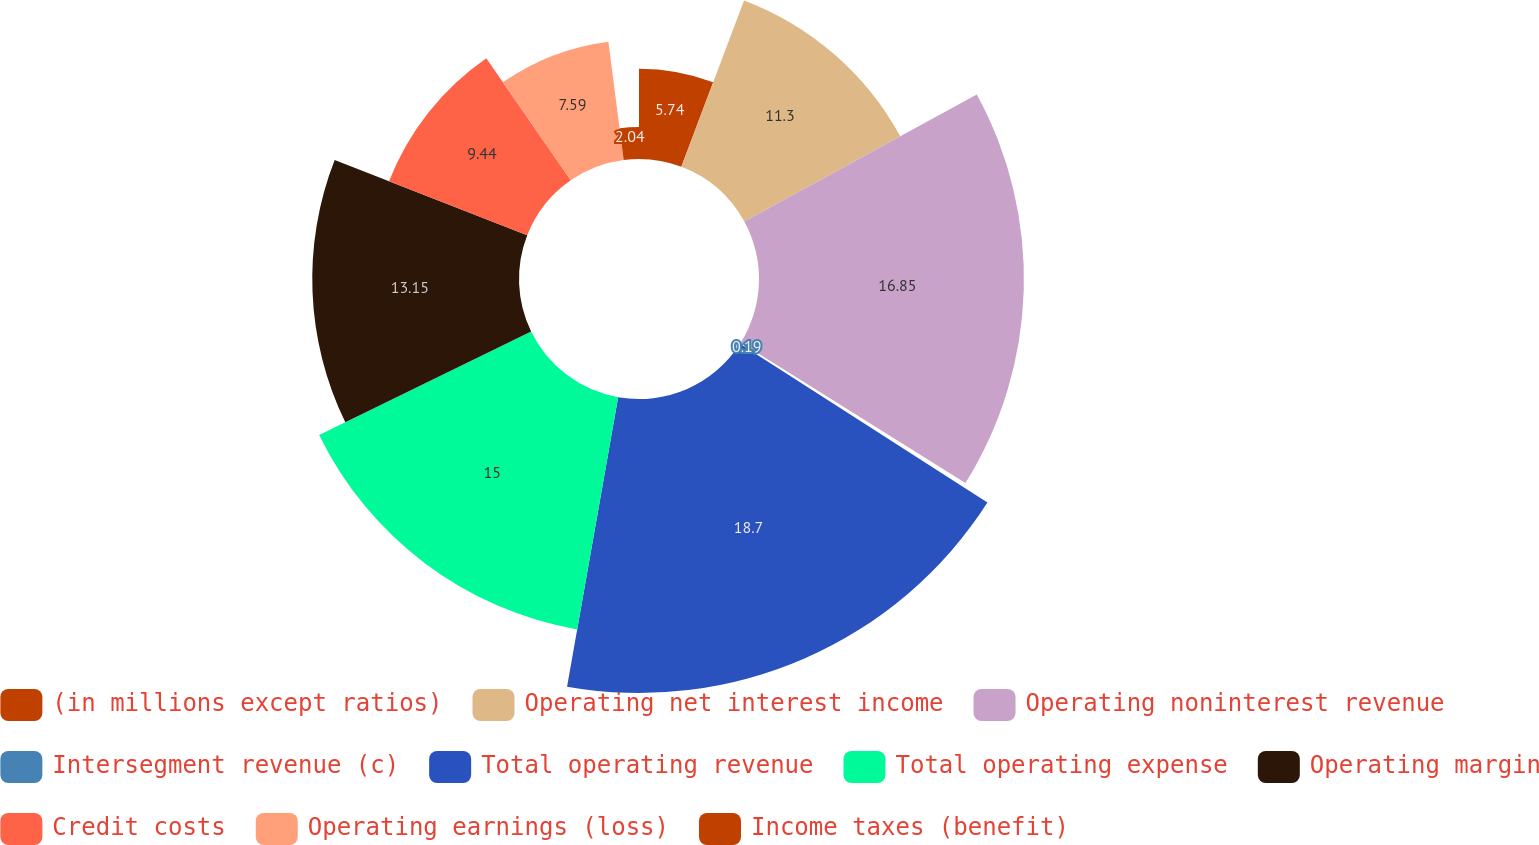Convert chart to OTSL. <chart><loc_0><loc_0><loc_500><loc_500><pie_chart><fcel>(in millions except ratios)<fcel>Operating net interest income<fcel>Operating noninterest revenue<fcel>Intersegment revenue (c)<fcel>Total operating revenue<fcel>Total operating expense<fcel>Operating margin<fcel>Credit costs<fcel>Operating earnings (loss)<fcel>Income taxes (benefit)<nl><fcel>5.74%<fcel>11.3%<fcel>16.85%<fcel>0.19%<fcel>18.7%<fcel>15.0%<fcel>13.15%<fcel>9.44%<fcel>7.59%<fcel>2.04%<nl></chart> 